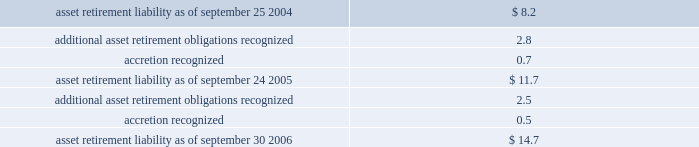Notes to consolidated financial statements ( continued ) note 1 2014summary of significant accounting policies ( continued ) present value is accreted over the life of the related lease as an operating expense .
All of the company 2019s existing asset retirement obligations are associated with commitments to return property subject to operating leases to original condition upon lease termination .
The table reconciles changes in the company 2019s asset retirement liabilities for fiscal 2006 and 2005 ( in millions ) : .
Long-lived assets including goodwill and other acquired intangible assets the company reviews property , plant , and equipment and certain identifiable intangibles , excluding goodwill , for impairment in accordance with sfas no .
144 , accounting for the impairment of long-lived assets and for long-lived assets to be disposed of .
Long-lived assets are reviewed for impairment whenever events or changes in circumstances indicate the carrying amount of an asset may not be recoverable .
Recoverability of these assets is measured by comparison of its carrying amount to future undiscounted cash flows the assets are expected to generate .
If property , plant , and equipment and certain identifiable intangibles are considered to be impaired , the impairment to be recognized equals the amount by which the carrying value of the assets exceeds its fair market value .
For the three fiscal years ended september 30 , 2006 , the company had no material impairment of its long-lived assets , except for the impairment of certain assets in connection with the restructuring actions described in note 6 of these notes to consolidated financial statements .
Sfas no .
142 , goodwill and other intangible assets requires that goodwill and intangible assets with indefinite useful lives should not be amortized but rather be tested for impairment at least annually or sooner whenever events or changes in circumstances indicate that they may be impaired .
The company performs its goodwill impairment tests on or about august 30 of each year .
The company did not recognize any goodwill or intangible asset impairment charges in 2006 , 2005 , or 2004 .
The company established reporting units based on its current reporting structure .
For purposes of testing goodwill for impairment , goodwill has been allocated to these reporting units to the extent it relates to each reporting sfas no .
142 also requires that intangible assets with definite lives be amortized over their estimated useful lives and reviewed for impairment in accordance with sfas no .
144 .
The company is currently amortizing its acquired intangible assets with definite lives over periods ranging from 3 to 10 years .
Foreign currency translation the company translates the assets and liabilities of its international non-u.s .
Functional currency subsidiaries into u.s .
Dollars using exchange rates in effect at the end of each period .
Revenue and expenses for these subsidiaries are translated using rates that approximate those in effect during the period .
Gains and losses from these translations are credited or charged to foreign currency translation .
By how much did asset retirement liability increase from 2005 to 2006? 
Computations: ((14.7 - 11.7) / 11.7)
Answer: 0.25641. Notes to consolidated financial statements ( continued ) note 1 2014summary of significant accounting policies ( continued ) present value is accreted over the life of the related lease as an operating expense .
All of the company 2019s existing asset retirement obligations are associated with commitments to return property subject to operating leases to original condition upon lease termination .
The table reconciles changes in the company 2019s asset retirement liabilities for fiscal 2006 and 2005 ( in millions ) : .
Long-lived assets including goodwill and other acquired intangible assets the company reviews property , plant , and equipment and certain identifiable intangibles , excluding goodwill , for impairment in accordance with sfas no .
144 , accounting for the impairment of long-lived assets and for long-lived assets to be disposed of .
Long-lived assets are reviewed for impairment whenever events or changes in circumstances indicate the carrying amount of an asset may not be recoverable .
Recoverability of these assets is measured by comparison of its carrying amount to future undiscounted cash flows the assets are expected to generate .
If property , plant , and equipment and certain identifiable intangibles are considered to be impaired , the impairment to be recognized equals the amount by which the carrying value of the assets exceeds its fair market value .
For the three fiscal years ended september 30 , 2006 , the company had no material impairment of its long-lived assets , except for the impairment of certain assets in connection with the restructuring actions described in note 6 of these notes to consolidated financial statements .
Sfas no .
142 , goodwill and other intangible assets requires that goodwill and intangible assets with indefinite useful lives should not be amortized but rather be tested for impairment at least annually or sooner whenever events or changes in circumstances indicate that they may be impaired .
The company performs its goodwill impairment tests on or about august 30 of each year .
The company did not recognize any goodwill or intangible asset impairment charges in 2006 , 2005 , or 2004 .
The company established reporting units based on its current reporting structure .
For purposes of testing goodwill for impairment , goodwill has been allocated to these reporting units to the extent it relates to each reporting sfas no .
142 also requires that intangible assets with definite lives be amortized over their estimated useful lives and reviewed for impairment in accordance with sfas no .
144 .
The company is currently amortizing its acquired intangible assets with definite lives over periods ranging from 3 to 10 years .
Foreign currency translation the company translates the assets and liabilities of its international non-u.s .
Functional currency subsidiaries into u.s .
Dollars using exchange rates in effect at the end of each period .
Revenue and expenses for these subsidiaries are translated using rates that approximate those in effect during the period .
Gains and losses from these translations are credited or charged to foreign currency translation .
By how much did asset retirement liability increase from 2004 to 2005? 
Computations: ((11.7 - 8.2) / 8.2)
Answer: 0.42683. Notes to consolidated financial statements ( continued ) note 1 2014summary of significant accounting policies ( continued ) present value is accreted over the life of the related lease as an operating expense .
All of the company 2019s existing asset retirement obligations are associated with commitments to return property subject to operating leases to original condition upon lease termination .
The table reconciles changes in the company 2019s asset retirement liabilities for fiscal 2006 and 2005 ( in millions ) : .
Long-lived assets including goodwill and other acquired intangible assets the company reviews property , plant , and equipment and certain identifiable intangibles , excluding goodwill , for impairment in accordance with sfas no .
144 , accounting for the impairment of long-lived assets and for long-lived assets to be disposed of .
Long-lived assets are reviewed for impairment whenever events or changes in circumstances indicate the carrying amount of an asset may not be recoverable .
Recoverability of these assets is measured by comparison of its carrying amount to future undiscounted cash flows the assets are expected to generate .
If property , plant , and equipment and certain identifiable intangibles are considered to be impaired , the impairment to be recognized equals the amount by which the carrying value of the assets exceeds its fair market value .
For the three fiscal years ended september 30 , 2006 , the company had no material impairment of its long-lived assets , except for the impairment of certain assets in connection with the restructuring actions described in note 6 of these notes to consolidated financial statements .
Sfas no .
142 , goodwill and other intangible assets requires that goodwill and intangible assets with indefinite useful lives should not be amortized but rather be tested for impairment at least annually or sooner whenever events or changes in circumstances indicate that they may be impaired .
The company performs its goodwill impairment tests on or about august 30 of each year .
The company did not recognize any goodwill or intangible asset impairment charges in 2006 , 2005 , or 2004 .
The company established reporting units based on its current reporting structure .
For purposes of testing goodwill for impairment , goodwill has been allocated to these reporting units to the extent it relates to each reporting sfas no .
142 also requires that intangible assets with definite lives be amortized over their estimated useful lives and reviewed for impairment in accordance with sfas no .
144 .
The company is currently amortizing its acquired intangible assets with definite lives over periods ranging from 3 to 10 years .
Foreign currency translation the company translates the assets and liabilities of its international non-u.s .
Functional currency subsidiaries into u.s .
Dollars using exchange rates in effect at the end of each period .
Revenue and expenses for these subsidiaries are translated using rates that approximate those in effect during the period .
Gains and losses from these translations are credited or charged to foreign currency translation .
What was the net change in millions in asset retirement liability between september 2005 and september 2004? 
Computations: (11.7 - 8.2)
Answer: 3.5. Notes to consolidated financial statements ( continued ) note 1 2014summary of significant accounting policies ( continued ) present value is accreted over the life of the related lease as an operating expense .
All of the company 2019s existing asset retirement obligations are associated with commitments to return property subject to operating leases to original condition upon lease termination .
The table reconciles changes in the company 2019s asset retirement liabilities for fiscal 2006 and 2005 ( in millions ) : .
Long-lived assets including goodwill and other acquired intangible assets the company reviews property , plant , and equipment and certain identifiable intangibles , excluding goodwill , for impairment in accordance with sfas no .
144 , accounting for the impairment of long-lived assets and for long-lived assets to be disposed of .
Long-lived assets are reviewed for impairment whenever events or changes in circumstances indicate the carrying amount of an asset may not be recoverable .
Recoverability of these assets is measured by comparison of its carrying amount to future undiscounted cash flows the assets are expected to generate .
If property , plant , and equipment and certain identifiable intangibles are considered to be impaired , the impairment to be recognized equals the amount by which the carrying value of the assets exceeds its fair market value .
For the three fiscal years ended september 30 , 2006 , the company had no material impairment of its long-lived assets , except for the impairment of certain assets in connection with the restructuring actions described in note 6 of these notes to consolidated financial statements .
Sfas no .
142 , goodwill and other intangible assets requires that goodwill and intangible assets with indefinite useful lives should not be amortized but rather be tested for impairment at least annually or sooner whenever events or changes in circumstances indicate that they may be impaired .
The company performs its goodwill impairment tests on or about august 30 of each year .
The company did not recognize any goodwill or intangible asset impairment charges in 2006 , 2005 , or 2004 .
The company established reporting units based on its current reporting structure .
For purposes of testing goodwill for impairment , goodwill has been allocated to these reporting units to the extent it relates to each reporting sfas no .
142 also requires that intangible assets with definite lives be amortized over their estimated useful lives and reviewed for impairment in accordance with sfas no .
144 .
The company is currently amortizing its acquired intangible assets with definite lives over periods ranging from 3 to 10 years .
Foreign currency translation the company translates the assets and liabilities of its international non-u.s .
Functional currency subsidiaries into u.s .
Dollars using exchange rates in effect at the end of each period .
Revenue and expenses for these subsidiaries are translated using rates that approximate those in effect during the period .
Gains and losses from these translations are credited or charged to foreign currency translation .
What was the net change in millions in asset retirement liability between september 24 2005 and september 30 2006? 
Computations: (14.7 - 11.7)
Answer: 3.0. 